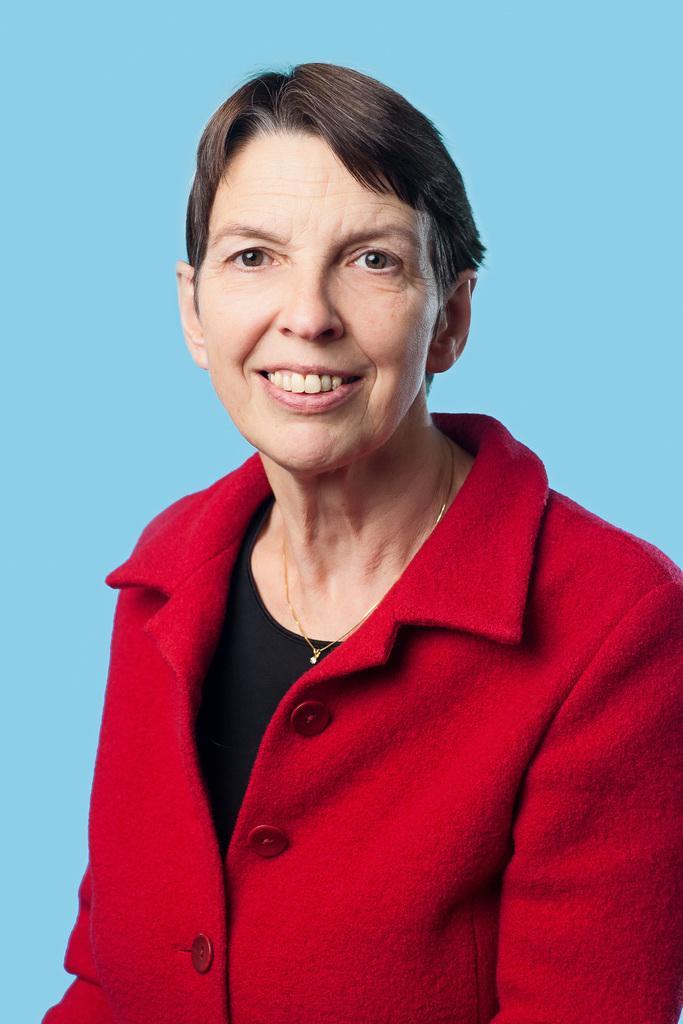Describe this image in one or two sentences. This image consists of a woman wearing a red coat. The background is in blue color. 